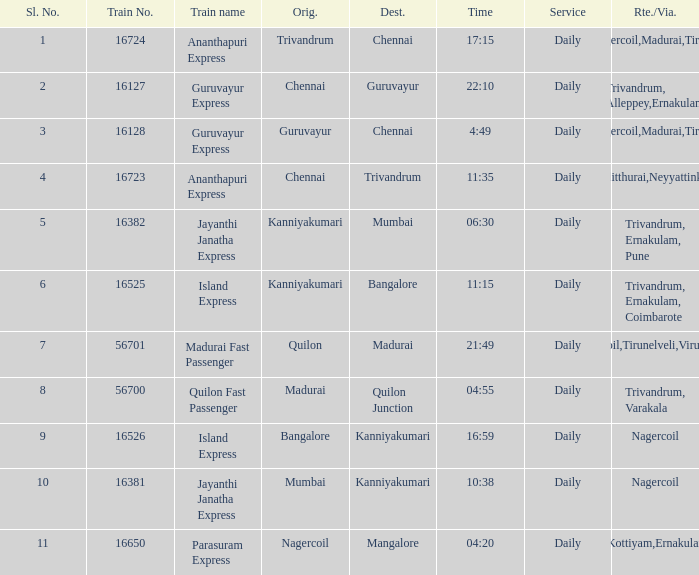What is the route/via when the train name is Parasuram Express? Trivandrum,Kottiyam,Ernakulam,Kozhikode. 